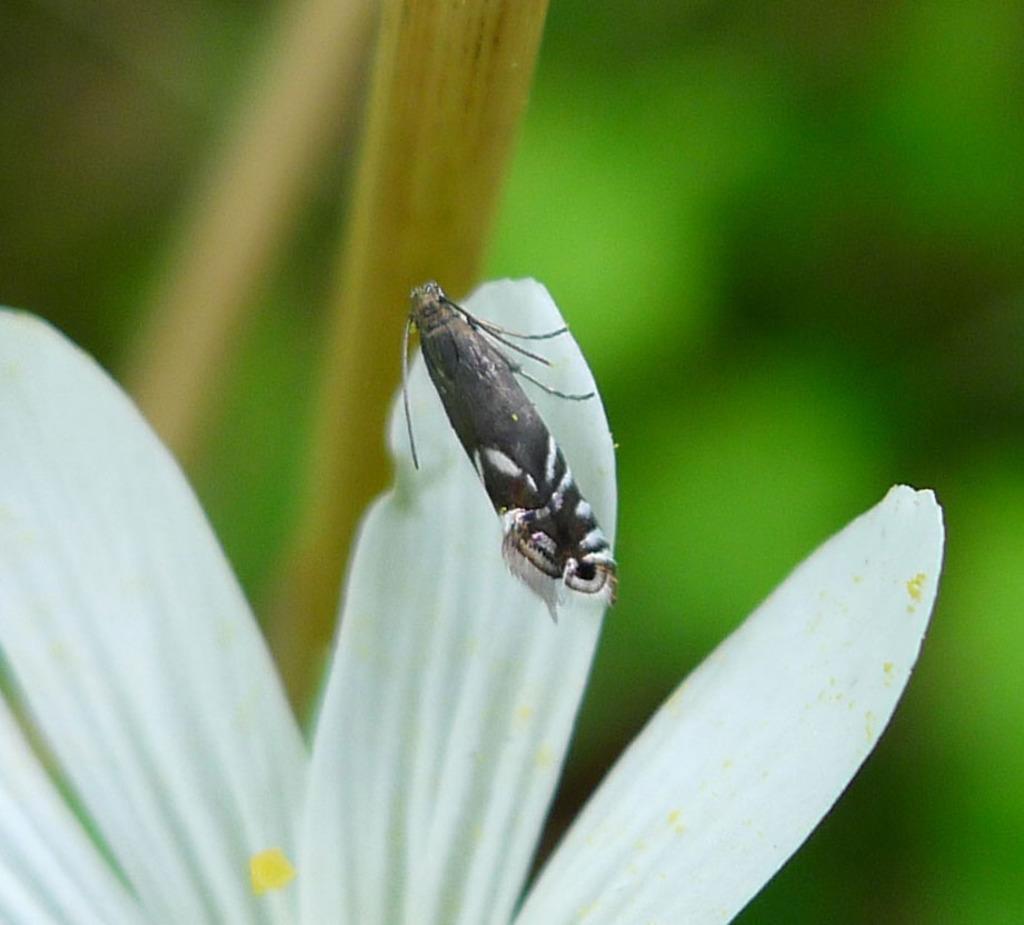In one or two sentences, can you explain what this image depicts? In this image there is a insect on a flower, in the background it is blurred. 